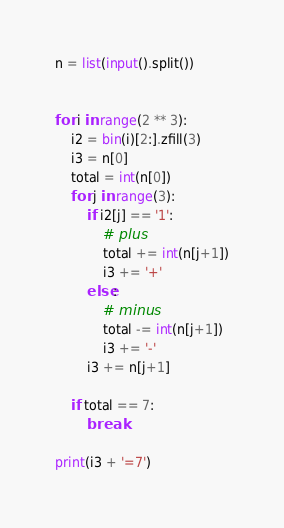<code> <loc_0><loc_0><loc_500><loc_500><_Python_>n = list(input().split())


for i in range(2 ** 3):
    i2 = bin(i)[2:].zfill(3)
    i3 = n[0]
    total = int(n[0])
    for j in range(3):
        if i2[j] == '1':
            # plus
            total += int(n[j+1])
            i3 += '+'
        else:
            # minus
            total -= int(n[j+1])
            i3 += '-'
        i3 += n[j+1]

    if total == 7:
        break

print(i3 + '=7')
</code> 